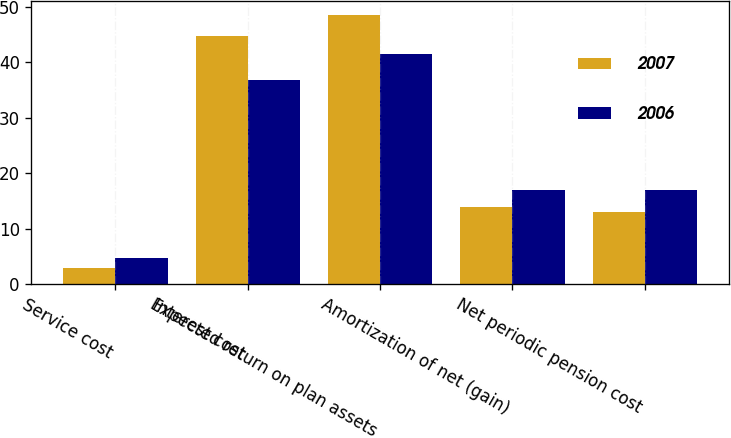Convert chart. <chart><loc_0><loc_0><loc_500><loc_500><stacked_bar_chart><ecel><fcel>Service cost<fcel>Interest cost<fcel>Expected return on plan assets<fcel>Amortization of net (gain)<fcel>Net periodic pension cost<nl><fcel>2007<fcel>3<fcel>44.7<fcel>48.6<fcel>14<fcel>13.1<nl><fcel>2006<fcel>4.7<fcel>36.9<fcel>41.5<fcel>16.9<fcel>17<nl></chart> 